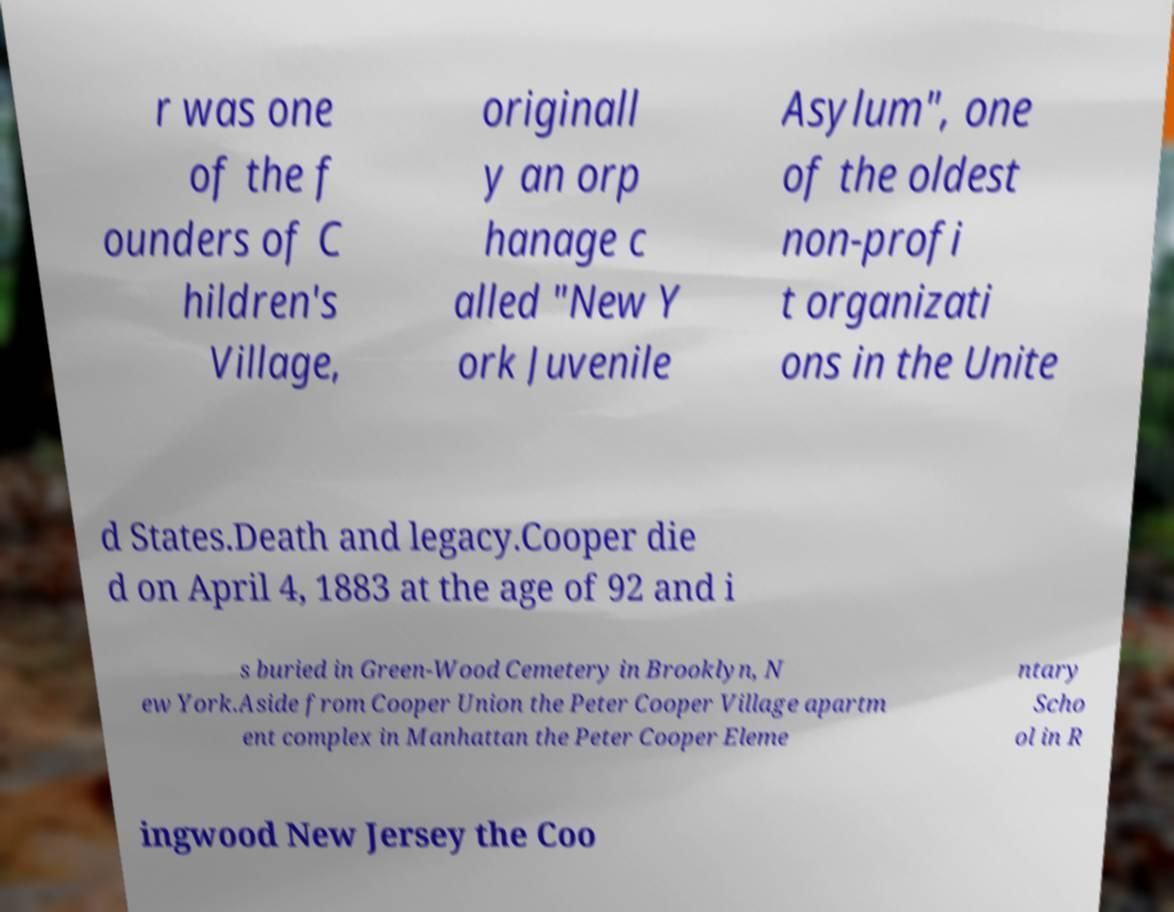Could you assist in decoding the text presented in this image and type it out clearly? r was one of the f ounders of C hildren's Village, originall y an orp hanage c alled "New Y ork Juvenile Asylum", one of the oldest non-profi t organizati ons in the Unite d States.Death and legacy.Cooper die d on April 4, 1883 at the age of 92 and i s buried in Green-Wood Cemetery in Brooklyn, N ew York.Aside from Cooper Union the Peter Cooper Village apartm ent complex in Manhattan the Peter Cooper Eleme ntary Scho ol in R ingwood New Jersey the Coo 